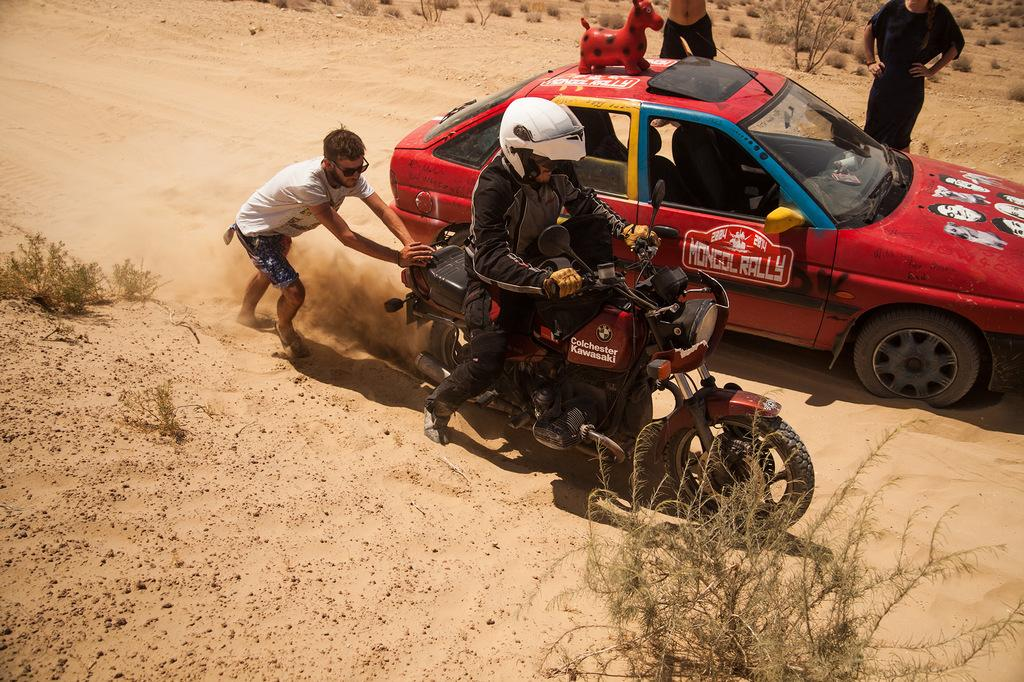What is the man in the image trying to do? The man is trying to ride a motorcycle. Who is assisting the man with the motorcycle? Another man is pushing the motorcycle from behind. What color is the car next to the motorcycle? The car is red. How many people are standing beside the car? There are two people standing beside the car. What type of animal is rubbing against the quartz in the image? There is no animal or quartz present in the image. 